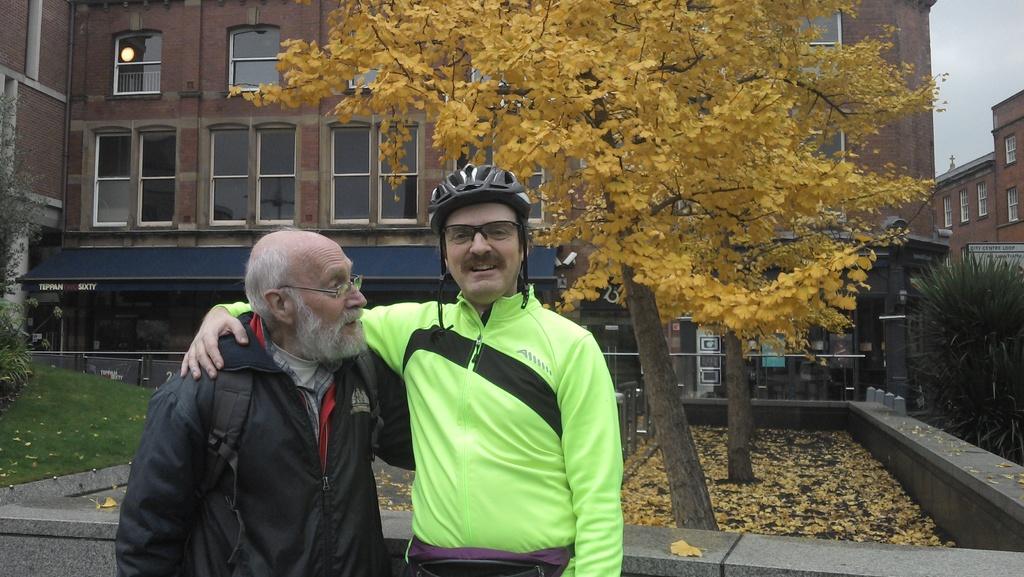In one or two sentences, can you explain what this image depicts? In this image in the front there are persons standing. In the background there are trees, there is grass on the ground, there are dry leaves on the ground, there are buildings and the sky is cloudy and the person standing in the front wearing a helmet is smiling. 